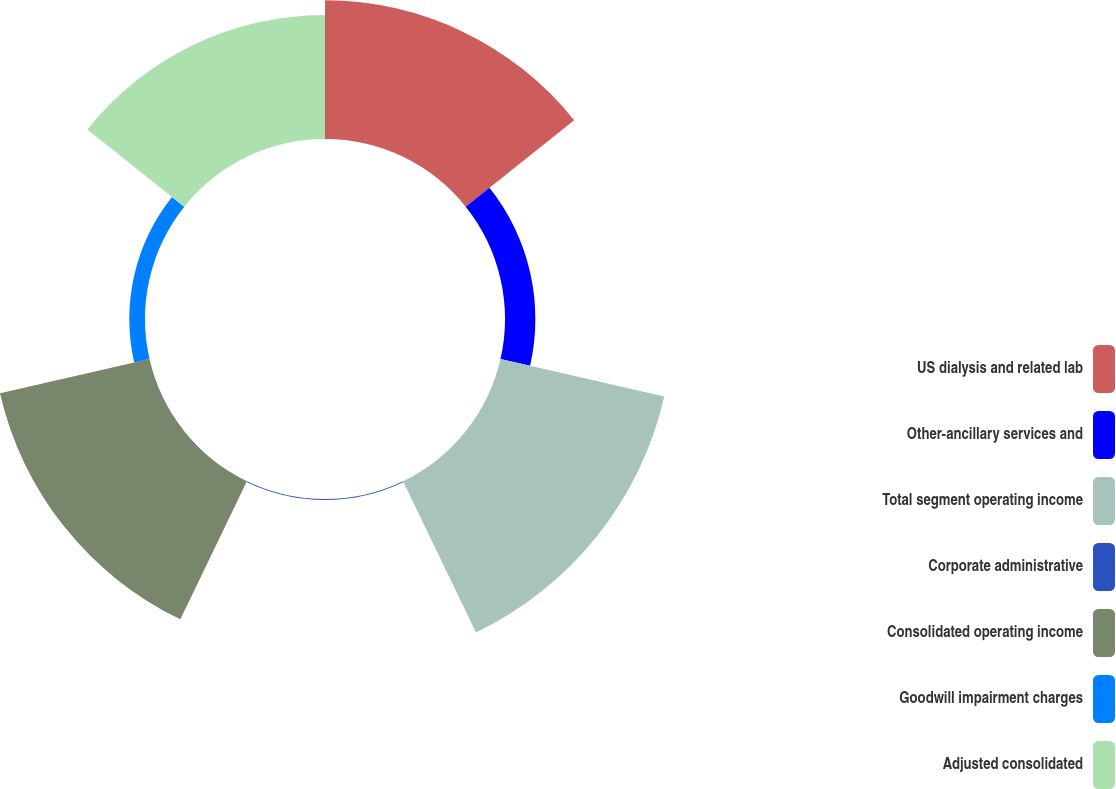<chart> <loc_0><loc_0><loc_500><loc_500><pie_chart><fcel>US dialysis and related lab<fcel>Other-ancillary services and<fcel>Total segment operating income<fcel>Corporate administrative<fcel>Consolidated operating income<fcel>Goodwill impairment charges<fcel>Adjusted consolidated<nl><fcel>21.97%<fcel>4.81%<fcel>26.62%<fcel>0.16%<fcel>24.3%<fcel>2.49%<fcel>19.65%<nl></chart> 